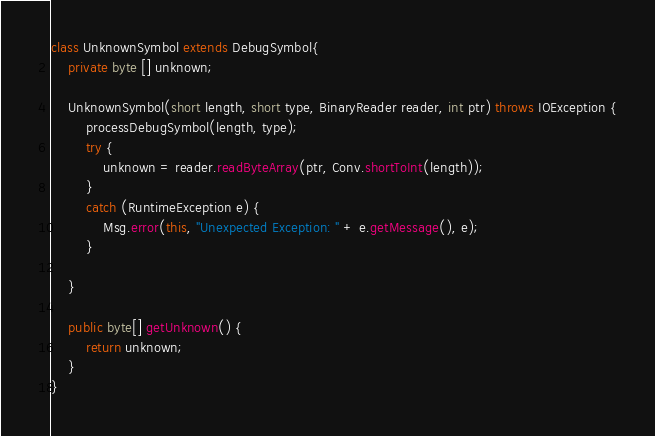<code> <loc_0><loc_0><loc_500><loc_500><_Java_>class UnknownSymbol extends DebugSymbol{
    private byte [] unknown;

	UnknownSymbol(short length, short type, BinaryReader reader, int ptr) throws IOException {
		processDebugSymbol(length, type);
		try {
			unknown = reader.readByteArray(ptr, Conv.shortToInt(length));
		}
		catch (RuntimeException e) {
		    Msg.error(this, "Unexpected Exception: " + e.getMessage(), e);
		}

	}

	public byte[] getUnknown() {
		return unknown;
	}
}
</code> 